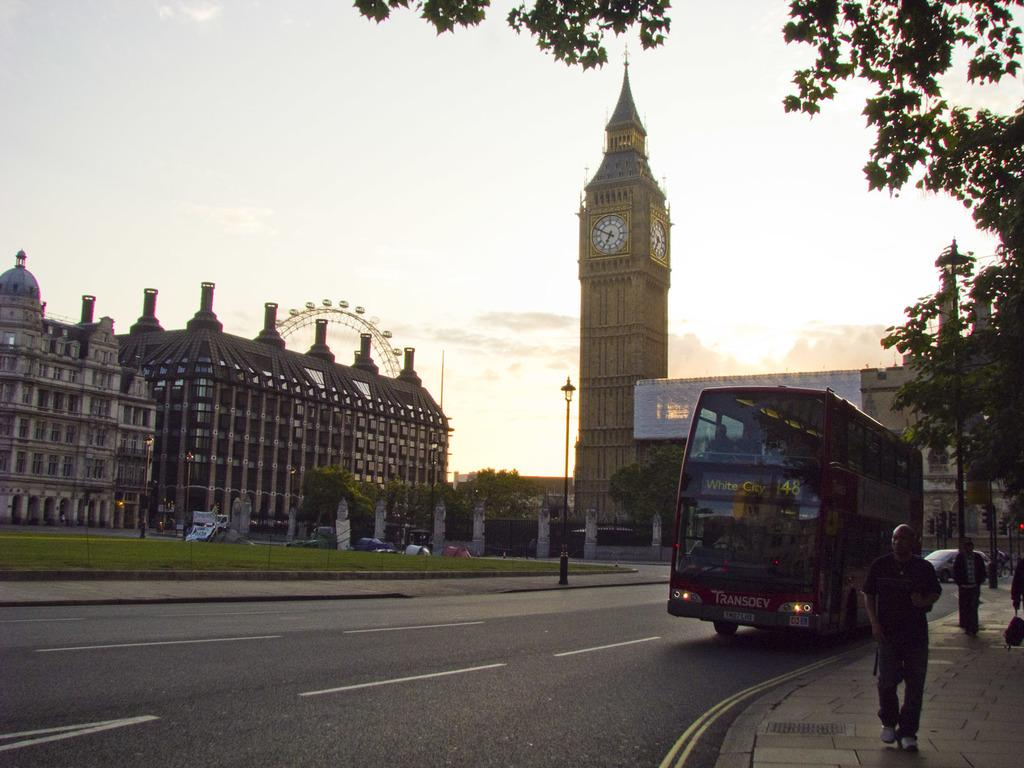<image>
Render a clear and concise summary of the photo. The double decker bus with route 148 is headed to White City. 